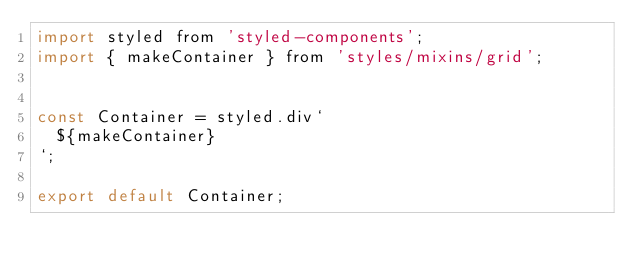Convert code to text. <code><loc_0><loc_0><loc_500><loc_500><_JavaScript_>import styled from 'styled-components';
import { makeContainer } from 'styles/mixins/grid';


const Container = styled.div`
  ${makeContainer}
`;

export default Container;
</code> 